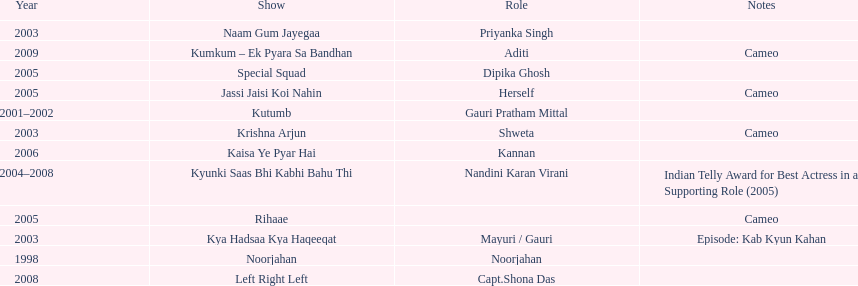Besides rihaae, in what other show did gauri tejwani cameo in 2005? Jassi Jaisi Koi Nahin. 